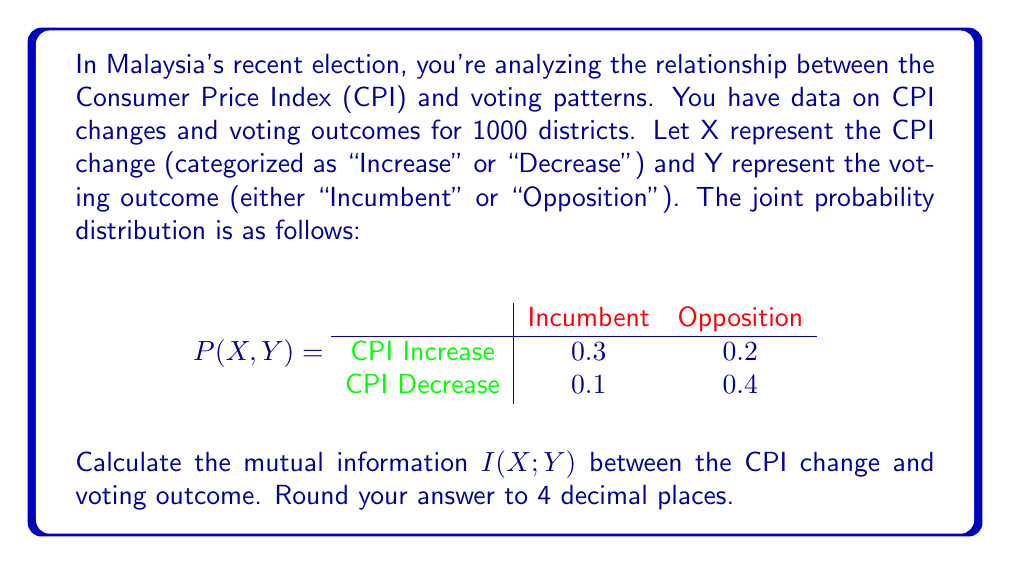Solve this math problem. To calculate the mutual information $I(X;Y)$, we'll follow these steps:

1) First, we need to calculate the marginal probabilities:

   $P(X = \text{Increase}) = 0.3 + 0.2 = 0.5$
   $P(X = \text{Decrease}) = 0.1 + 0.4 = 0.5$
   $P(Y = \text{Incumbent}) = 0.3 + 0.1 = 0.4$
   $P(Y = \text{Opposition}) = 0.2 + 0.4 = 0.6$

2) The mutual information is defined as:

   $$I(X;Y) = \sum_{x \in X} \sum_{y \in Y} P(x,y) \log_2 \frac{P(x,y)}{P(x)P(y)}$$

3) Let's calculate each term:

   For $X = \text{Increase}, Y = \text{Incumbent}$:
   $$0.3 \log_2 \frac{0.3}{0.5 \times 0.4} = 0.3 \log_2 1.5 = 0.1699$$

   For $X = \text{Increase}, Y = \text{Opposition}$:
   $$0.2 \log_2 \frac{0.2}{0.5 \times 0.6} = 0.2 \log_2 0.6667 = -0.0899$$

   For $X = \text{Decrease}, Y = \text{Incumbent}$:
   $$0.1 \log_2 \frac{0.1}{0.5 \times 0.4} = 0.1 \log_2 0.5 = -0.1000$$

   For $X = \text{Decrease}, Y = \text{Opposition}$:
   $$0.4 \log_2 \frac{0.4}{0.5 \times 0.6} = 0.4 \log_2 1.3333 = 0.1510$$

4) Sum all these terms:

   $$I(X;Y) = 0.1699 + (-0.0899) + (-0.1000) + 0.1510 = 0.1310$$

5) Rounding to 4 decimal places:

   $$I(X;Y) \approx 0.1310$$

This result indicates a moderate level of mutual information between CPI changes and voting outcomes, suggesting some correlation between economic indicators and election results in Malaysia.
Answer: 0.1310 bits 